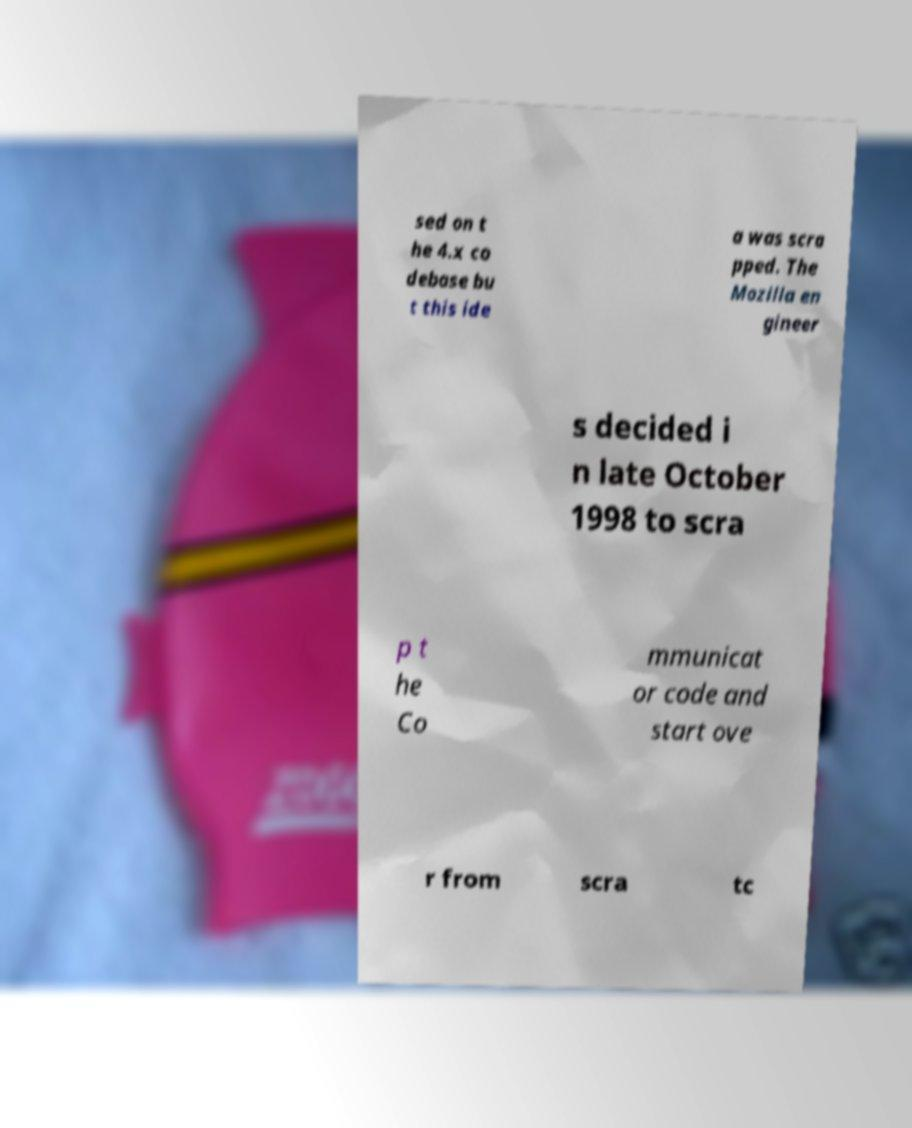Can you accurately transcribe the text from the provided image for me? sed on t he 4.x co debase bu t this ide a was scra pped. The Mozilla en gineer s decided i n late October 1998 to scra p t he Co mmunicat or code and start ove r from scra tc 